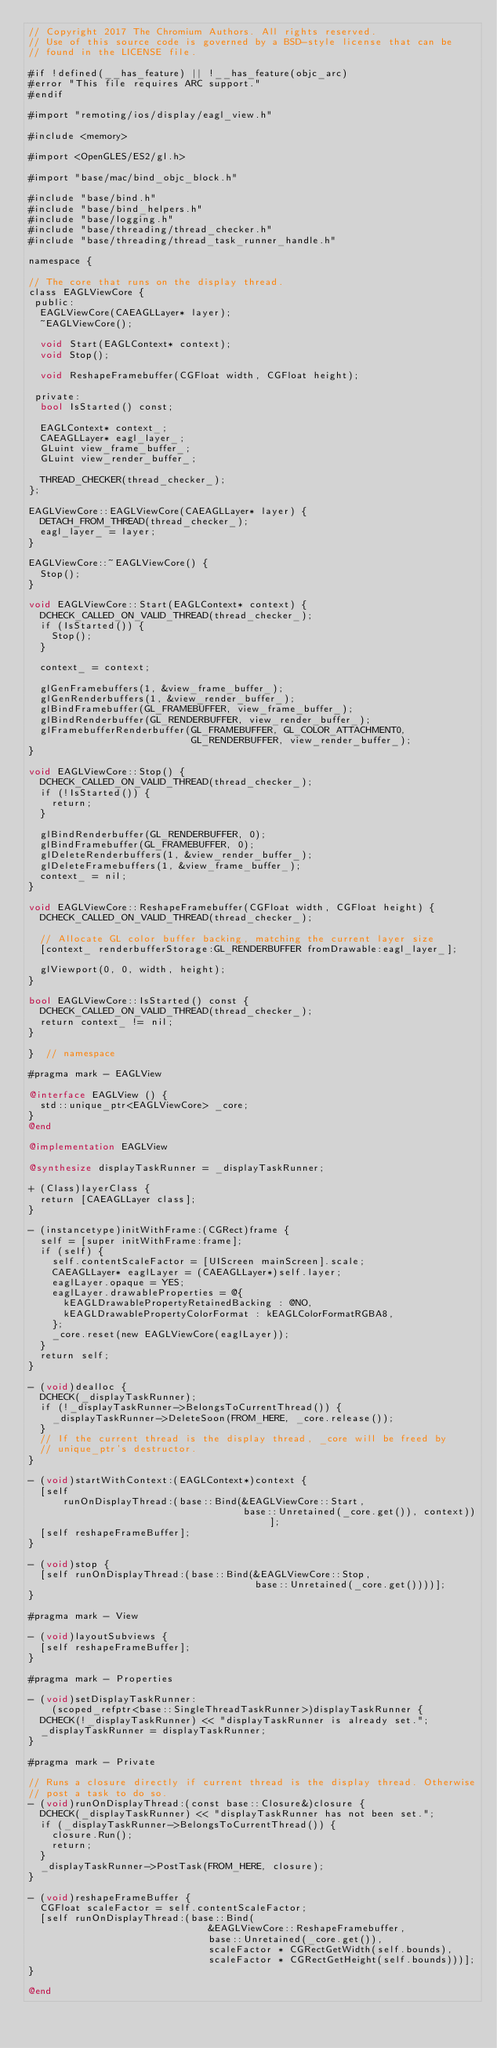<code> <loc_0><loc_0><loc_500><loc_500><_ObjectiveC_>// Copyright 2017 The Chromium Authors. All rights reserved.
// Use of this source code is governed by a BSD-style license that can be
// found in the LICENSE file.

#if !defined(__has_feature) || !__has_feature(objc_arc)
#error "This file requires ARC support."
#endif

#import "remoting/ios/display/eagl_view.h"

#include <memory>

#import <OpenGLES/ES2/gl.h>

#import "base/mac/bind_objc_block.h"

#include "base/bind.h"
#include "base/bind_helpers.h"
#include "base/logging.h"
#include "base/threading/thread_checker.h"
#include "base/threading/thread_task_runner_handle.h"

namespace {

// The core that runs on the display thread.
class EAGLViewCore {
 public:
  EAGLViewCore(CAEAGLLayer* layer);
  ~EAGLViewCore();

  void Start(EAGLContext* context);
  void Stop();

  void ReshapeFramebuffer(CGFloat width, CGFloat height);

 private:
  bool IsStarted() const;

  EAGLContext* context_;
  CAEAGLLayer* eagl_layer_;
  GLuint view_frame_buffer_;
  GLuint view_render_buffer_;

  THREAD_CHECKER(thread_checker_);
};

EAGLViewCore::EAGLViewCore(CAEAGLLayer* layer) {
  DETACH_FROM_THREAD(thread_checker_);
  eagl_layer_ = layer;
}

EAGLViewCore::~EAGLViewCore() {
  Stop();
}

void EAGLViewCore::Start(EAGLContext* context) {
  DCHECK_CALLED_ON_VALID_THREAD(thread_checker_);
  if (IsStarted()) {
    Stop();
  }

  context_ = context;

  glGenFramebuffers(1, &view_frame_buffer_);
  glGenRenderbuffers(1, &view_render_buffer_);
  glBindFramebuffer(GL_FRAMEBUFFER, view_frame_buffer_);
  glBindRenderbuffer(GL_RENDERBUFFER, view_render_buffer_);
  glFramebufferRenderbuffer(GL_FRAMEBUFFER, GL_COLOR_ATTACHMENT0,
                            GL_RENDERBUFFER, view_render_buffer_);
}

void EAGLViewCore::Stop() {
  DCHECK_CALLED_ON_VALID_THREAD(thread_checker_);
  if (!IsStarted()) {
    return;
  }

  glBindRenderbuffer(GL_RENDERBUFFER, 0);
  glBindFramebuffer(GL_FRAMEBUFFER, 0);
  glDeleteRenderbuffers(1, &view_render_buffer_);
  glDeleteFramebuffers(1, &view_frame_buffer_);
  context_ = nil;
}

void EAGLViewCore::ReshapeFramebuffer(CGFloat width, CGFloat height) {
  DCHECK_CALLED_ON_VALID_THREAD(thread_checker_);

  // Allocate GL color buffer backing, matching the current layer size
  [context_ renderbufferStorage:GL_RENDERBUFFER fromDrawable:eagl_layer_];

  glViewport(0, 0, width, height);
}

bool EAGLViewCore::IsStarted() const {
  DCHECK_CALLED_ON_VALID_THREAD(thread_checker_);
  return context_ != nil;
}

}  // namespace

#pragma mark - EAGLView

@interface EAGLView () {
  std::unique_ptr<EAGLViewCore> _core;
}
@end

@implementation EAGLView

@synthesize displayTaskRunner = _displayTaskRunner;

+ (Class)layerClass {
  return [CAEAGLLayer class];
}

- (instancetype)initWithFrame:(CGRect)frame {
  self = [super initWithFrame:frame];
  if (self) {
    self.contentScaleFactor = [UIScreen mainScreen].scale;
    CAEAGLLayer* eaglLayer = (CAEAGLLayer*)self.layer;
    eaglLayer.opaque = YES;
    eaglLayer.drawableProperties = @{
      kEAGLDrawablePropertyRetainedBacking : @NO,
      kEAGLDrawablePropertyColorFormat : kEAGLColorFormatRGBA8,
    };
    _core.reset(new EAGLViewCore(eaglLayer));
  }
  return self;
}

- (void)dealloc {
  DCHECK(_displayTaskRunner);
  if (!_displayTaskRunner->BelongsToCurrentThread()) {
    _displayTaskRunner->DeleteSoon(FROM_HERE, _core.release());
  }
  // If the current thread is the display thread, _core will be freed by
  // unique_ptr's destructor.
}

- (void)startWithContext:(EAGLContext*)context {
  [self
      runOnDisplayThread:(base::Bind(&EAGLViewCore::Start,
                                     base::Unretained(_core.get()), context))];
  [self reshapeFrameBuffer];
}

- (void)stop {
  [self runOnDisplayThread:(base::Bind(&EAGLViewCore::Stop,
                                       base::Unretained(_core.get())))];
}

#pragma mark - View

- (void)layoutSubviews {
  [self reshapeFrameBuffer];
}

#pragma mark - Properties

- (void)setDisplayTaskRunner:
    (scoped_refptr<base::SingleThreadTaskRunner>)displayTaskRunner {
  DCHECK(!_displayTaskRunner) << "displayTaskRunner is already set.";
  _displayTaskRunner = displayTaskRunner;
}

#pragma mark - Private

// Runs a closure directly if current thread is the display thread. Otherwise
// post a task to do so.
- (void)runOnDisplayThread:(const base::Closure&)closure {
  DCHECK(_displayTaskRunner) << "displayTaskRunner has not been set.";
  if (_displayTaskRunner->BelongsToCurrentThread()) {
    closure.Run();
    return;
  }
  _displayTaskRunner->PostTask(FROM_HERE, closure);
}

- (void)reshapeFrameBuffer {
  CGFloat scaleFactor = self.contentScaleFactor;
  [self runOnDisplayThread:(base::Bind(
                               &EAGLViewCore::ReshapeFramebuffer,
                               base::Unretained(_core.get()),
                               scaleFactor * CGRectGetWidth(self.bounds),
                               scaleFactor * CGRectGetHeight(self.bounds)))];
}

@end
</code> 